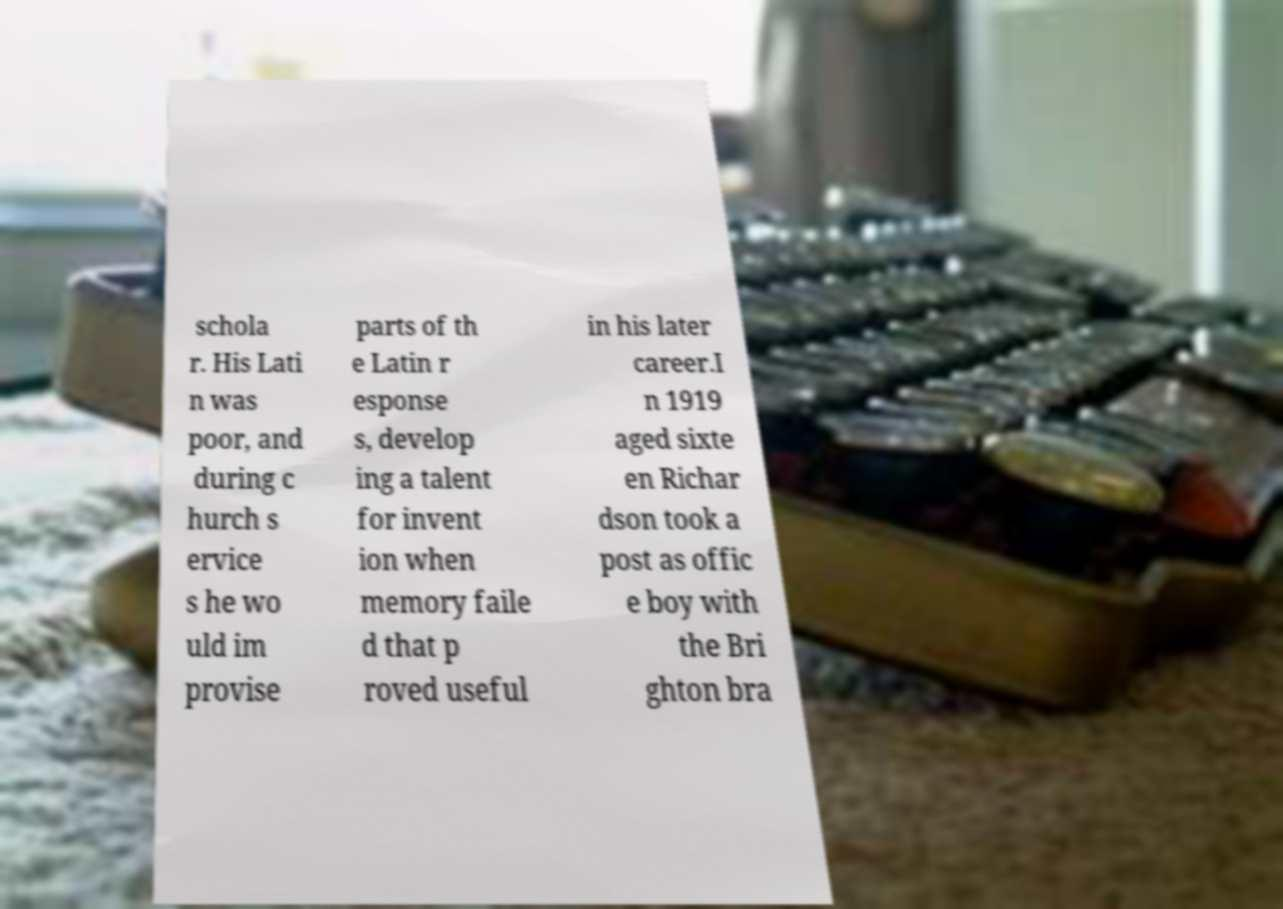I need the written content from this picture converted into text. Can you do that? schola r. His Lati n was poor, and during c hurch s ervice s he wo uld im provise parts of th e Latin r esponse s, develop ing a talent for invent ion when memory faile d that p roved useful in his later career.I n 1919 aged sixte en Richar dson took a post as offic e boy with the Bri ghton bra 